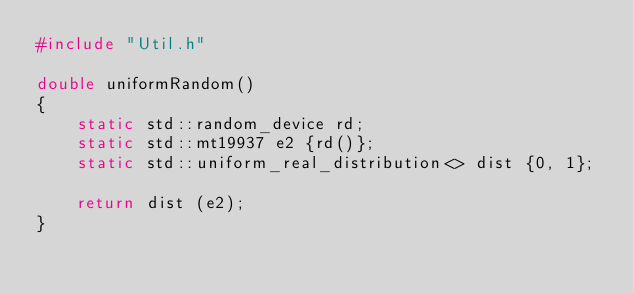Convert code to text. <code><loc_0><loc_0><loc_500><loc_500><_C++_>#include "Util.h"

double uniformRandom()
{
    static std::random_device rd;
    static std::mt19937 e2 {rd()};
    static std::uniform_real_distribution<> dist {0, 1};

    return dist (e2);
}
</code> 